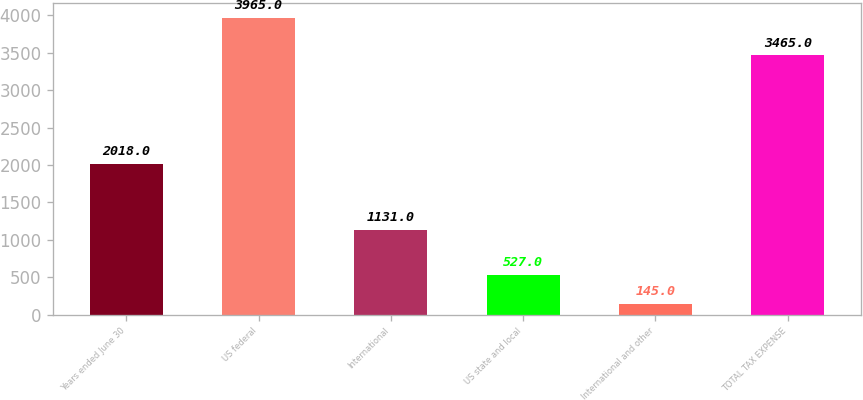Convert chart. <chart><loc_0><loc_0><loc_500><loc_500><bar_chart><fcel>Years ended June 30<fcel>US federal<fcel>International<fcel>US state and local<fcel>International and other<fcel>TOTAL TAX EXPENSE<nl><fcel>2018<fcel>3965<fcel>1131<fcel>527<fcel>145<fcel>3465<nl></chart> 